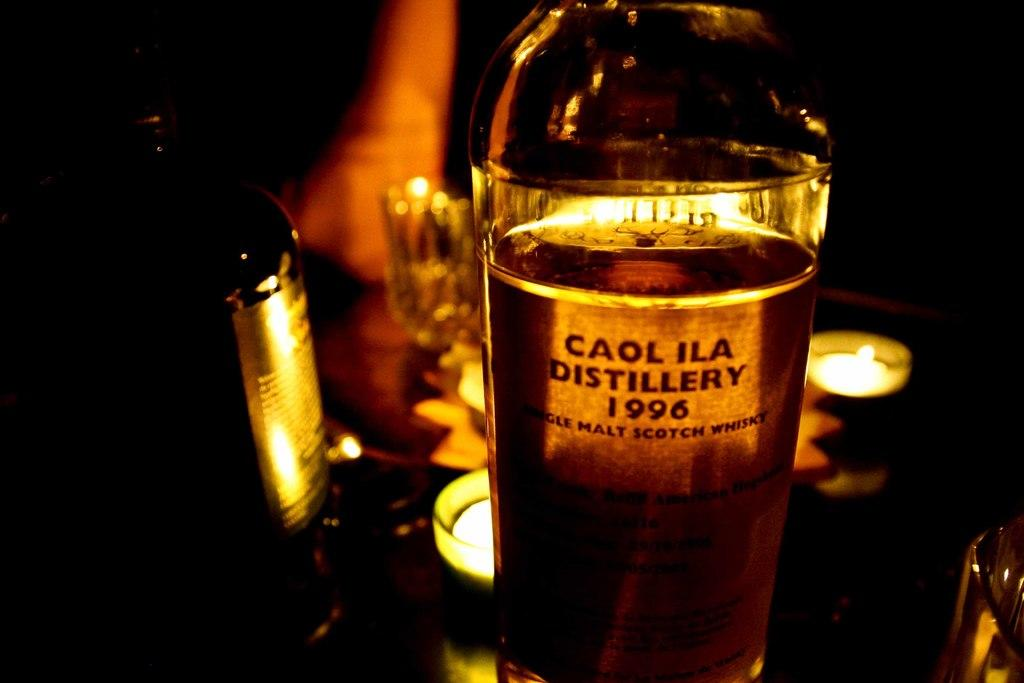<image>
Present a compact description of the photo's key features. a container with liquid that reads caol ila 